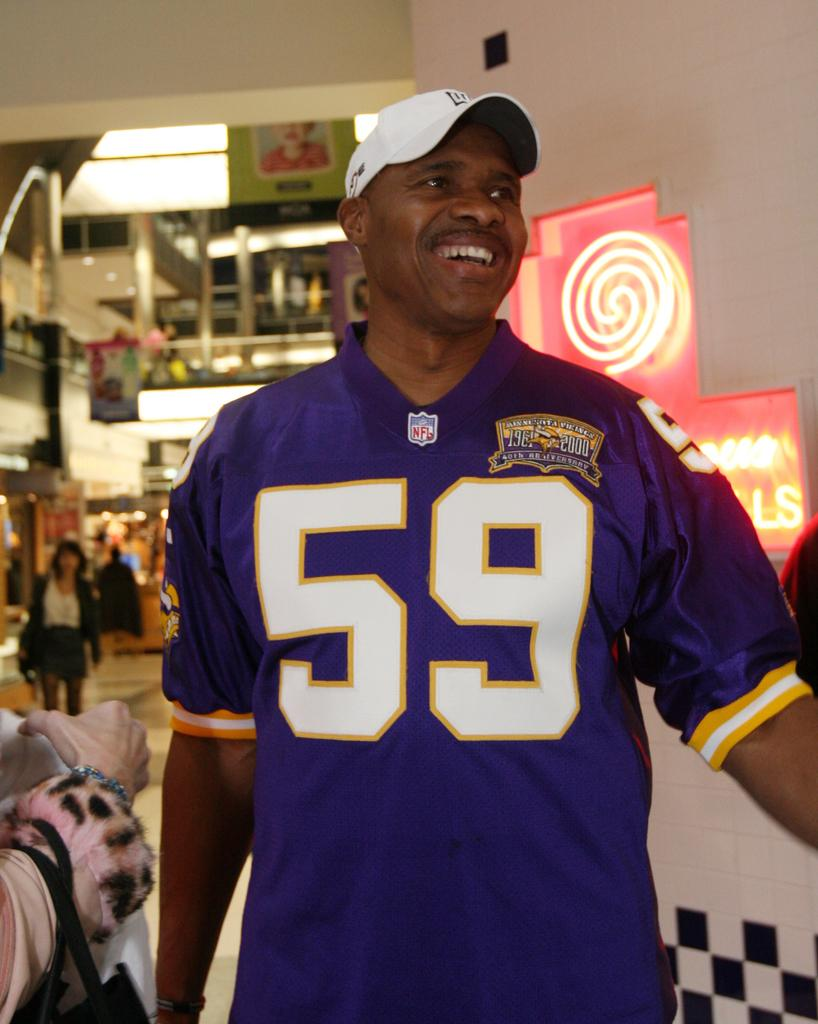<image>
Summarize the visual content of the image. Man wearing a purple jersey with the number 59 on it. 